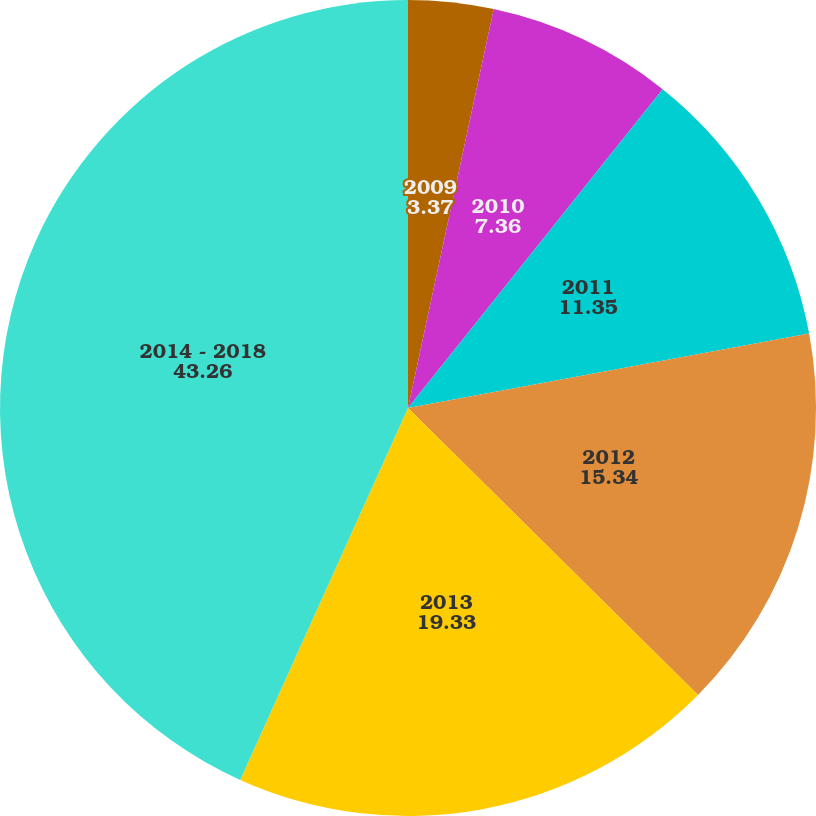<chart> <loc_0><loc_0><loc_500><loc_500><pie_chart><fcel>2009<fcel>2010<fcel>2011<fcel>2012<fcel>2013<fcel>2014 - 2018<nl><fcel>3.37%<fcel>7.36%<fcel>11.35%<fcel>15.34%<fcel>19.33%<fcel>43.26%<nl></chart> 